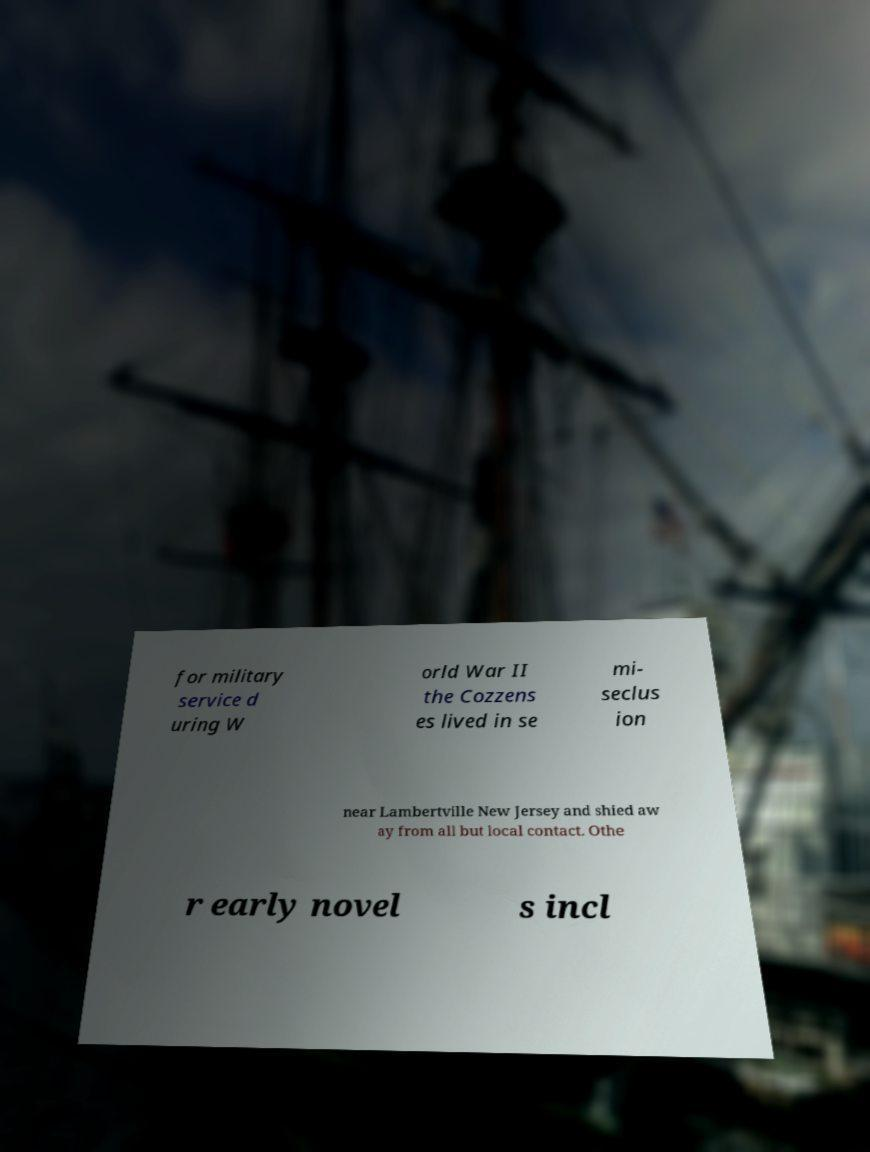What messages or text are displayed in this image? I need them in a readable, typed format. for military service d uring W orld War II the Cozzens es lived in se mi- seclus ion near Lambertville New Jersey and shied aw ay from all but local contact. Othe r early novel s incl 